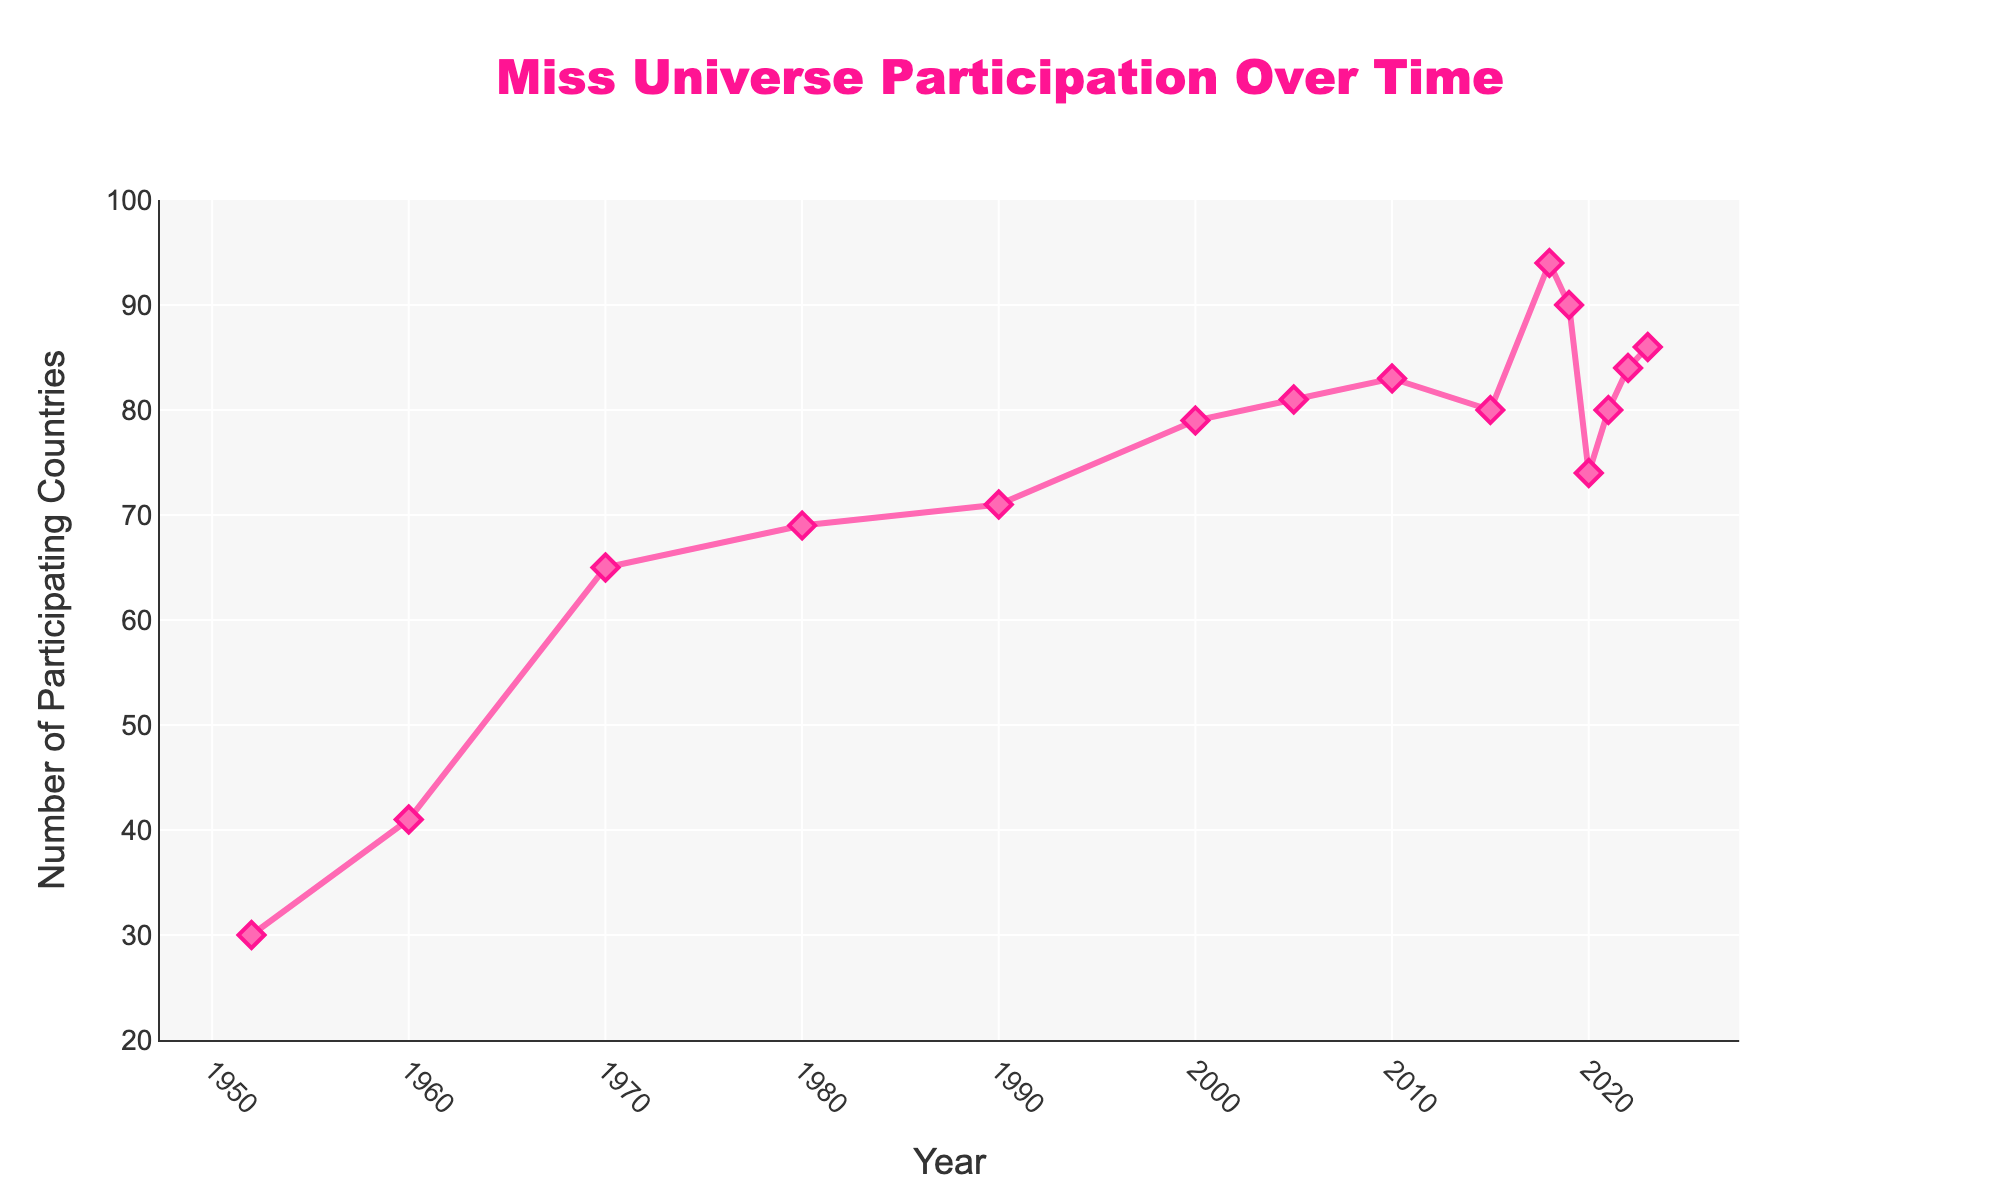How many times did the number of participating countries decrease from one year to the next between 2000 and 2023? Examine the data points between 2000 and 2023. Specifically, the participation decreased from 2010 to 2015 (83 to 80), from 2018 to 2019 (94 to 90), from 2019 to 2020 (90 to 74), and from 2022 to 2023 (84 to 86). Count these occurrences.
Answer: 4 From 1952 to 2023, what is the overall increase in the number of participating countries? Subtract the number of participating countries in 1952 from that in 2023 (86 - 30).
Answer: 56 What is the average number of participating countries from 2010 to 2023? Add the number of participating countries from 2010, 2015, 2018, 2019, 2020, 2021, 2022, and 2023, then divide by the number of years. (83 + 80 + 94 + 90 + 74 + 80 + 84 + 86) / 8 = 83.375
Answer: 83.375 Which year had the highest number of participating countries and how many were there? Look for the peak in the data points. The year with the highest number of participating countries is 2018 with 94 countries.
Answer: 2018, 94 How did the number of participating countries change between 1960 and 1970, and what was the percentage increase? Subtract the number of participating countries in 1960 from 1970 (65 - 41), then divide the result by the number in 1960 and multiply by 100 to find the percentage increase. ((65 - 41) / 41) * 100 = 58.54%
Answer: Increased by 58.54% Compare the number of participating countries in 1980 and 1990. Was there an increase or decrease, and by how much? Subtract the number of participating countries in 1980 from that in 1990 (71 - 69). Since the result is positive, it was an increase.
Answer: Increase by 2 Estimate the longest period during which the number of participating countries remained relatively stable (with changes of 5 or fewer countries). Identify the period and the range. From 2000 to 2005, the numbers are 79 and 81, respectively, representing stability. Also, between 2010 and 2021, the range is relatively stable but includes larger changes in 2020. The most stable period is from 2000 to 2005.
Answer: 2000 to 2005, range of around 2 What is the trend in the number of participating countries during the 2015-2023 period? Observe the data from 2015 to 2023. There are fluctuations but generally, the trend shows an increase with minor decreases in certain years.
Answer: Increasing trend with fluctuations In what year did the number of participating countries return to the same level as it was in 2000? Find the number of participating countries in 2000 (79) and search for the next occurrence of the same number. It returns to 79 in 2000 and never hits 79 again.
Answer: Never again returned to 79 